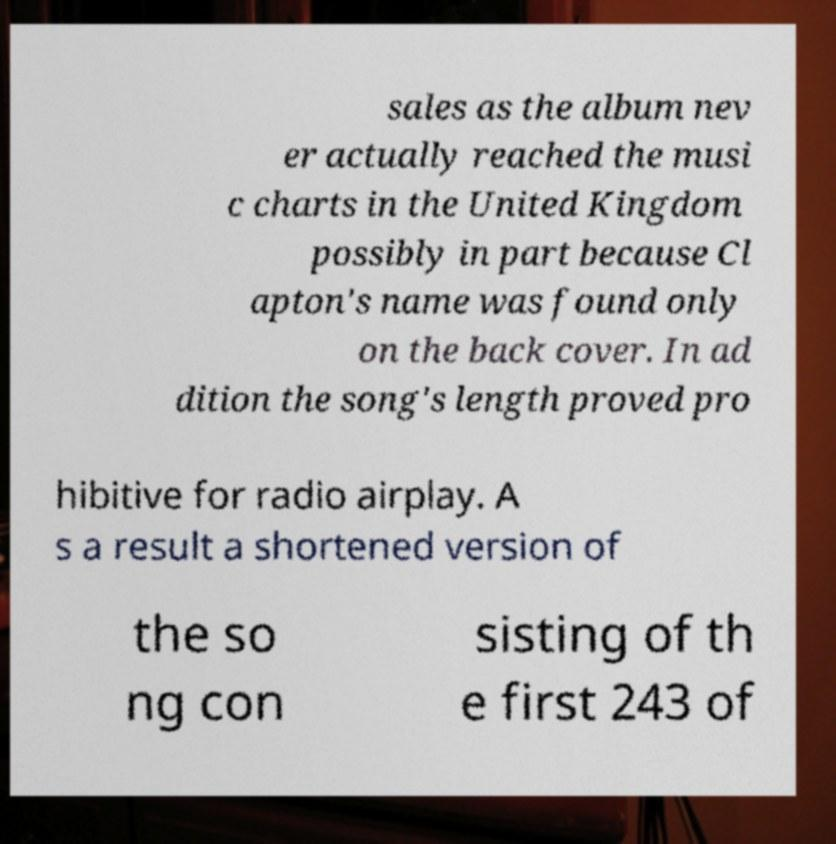Can you read and provide the text displayed in the image?This photo seems to have some interesting text. Can you extract and type it out for me? sales as the album nev er actually reached the musi c charts in the United Kingdom possibly in part because Cl apton's name was found only on the back cover. In ad dition the song's length proved pro hibitive for radio airplay. A s a result a shortened version of the so ng con sisting of th e first 243 of 